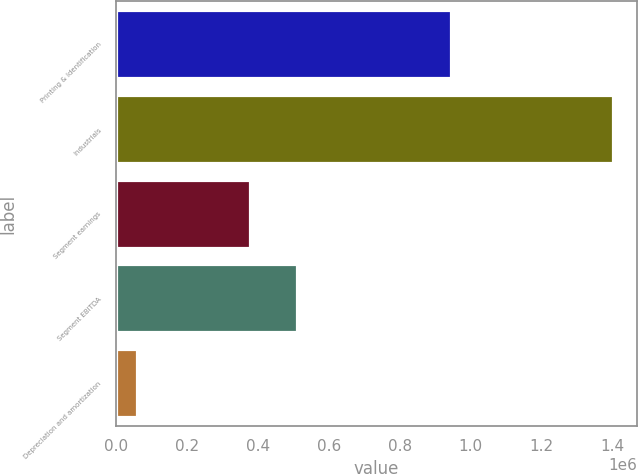<chart> <loc_0><loc_0><loc_500><loc_500><bar_chart><fcel>Printing & Identification<fcel>Industrials<fcel>Segment earnings<fcel>Segment EBITDA<fcel>Depreciation and amortization<nl><fcel>943670<fcel>1.39924e+06<fcel>376961<fcel>510894<fcel>59914<nl></chart> 